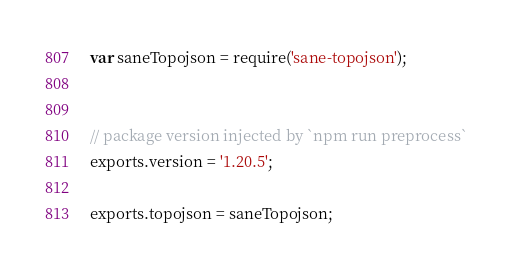Convert code to text. <code><loc_0><loc_0><loc_500><loc_500><_JavaScript_>var saneTopojson = require('sane-topojson');


// package version injected by `npm run preprocess`
exports.version = '1.20.5';

exports.topojson = saneTopojson;
</code> 